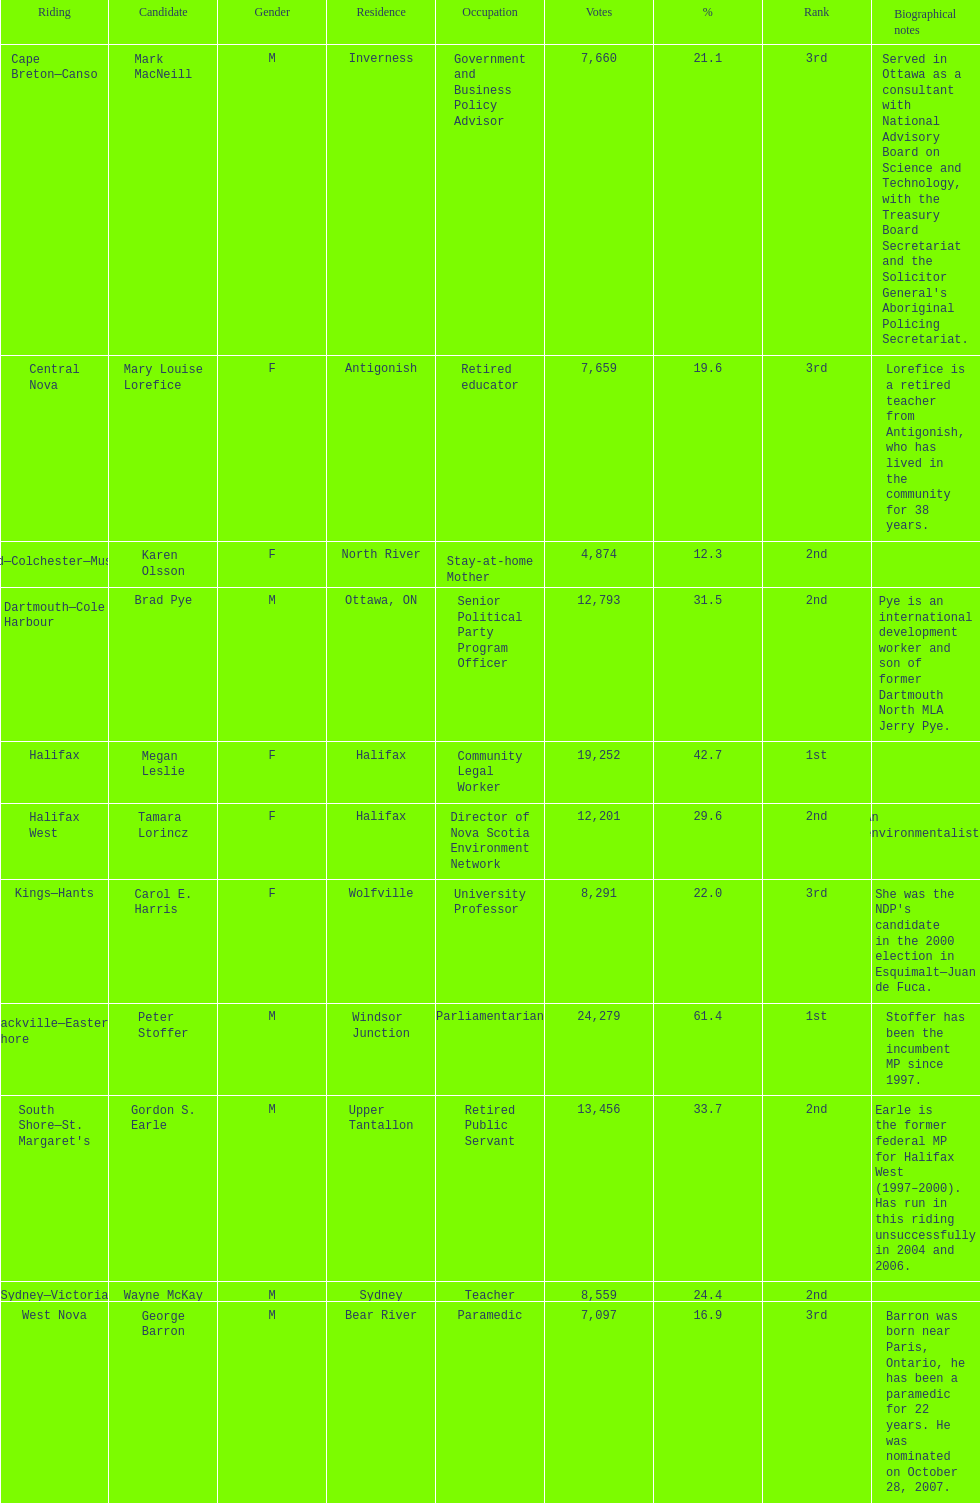Who obtained the lowest vote count? Karen Olsson. 